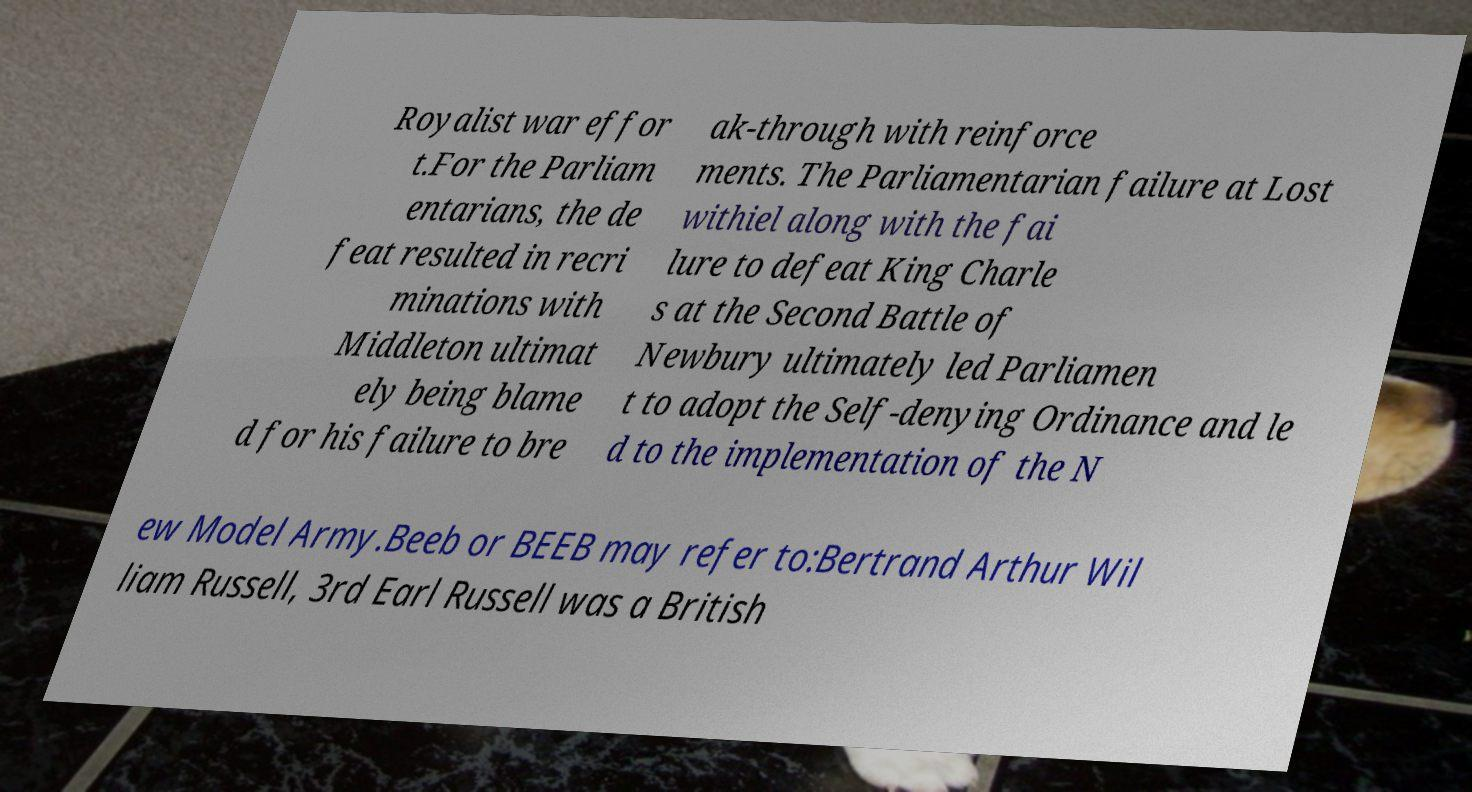Could you explain the historical significance of the New Model Army mentioned in the text? The New Model Army, formed in 1645 during the English Civil War, represented a significant military innovation. It was the first army funded by Parliament instead of the Crown, and it was composed of soldiers loyal to the parliamentary cause rather than to local nobles. It was crucial in turning the tide in favor of the Parliamentarians, leading to the defeat of Royalist forces and influencing the future of English military and political landscapes. 